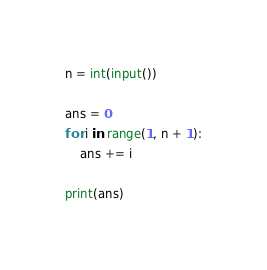Convert code to text. <code><loc_0><loc_0><loc_500><loc_500><_Python_>n = int(input())

ans = 0
for i in range(1, n + 1):
    ans += i

print(ans)
</code> 